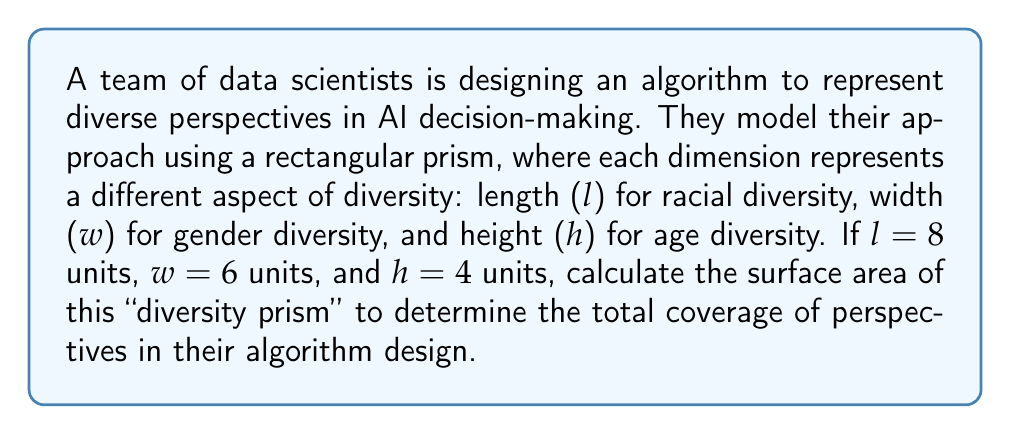Provide a solution to this math problem. To calculate the surface area of a rectangular prism, we need to follow these steps:

1. Recall the formula for the surface area of a rectangular prism:
   $$SA = 2(lw + lh + wh)$$
   where $l$ is length, $w$ is width, and $h$ is height.

2. Substitute the given values:
   $l = 8$, $w = 6$, $h = 4$

3. Calculate each face area:
   - Front/Back face: $lh = 8 \times 4 = 32$
   - Top/Bottom face: $lw = 8 \times 6 = 48$
   - Left/Right face: $wh = 6 \times 4 = 24$

4. Apply the formula:
   $$SA = 2(48 + 32 + 24)$$

5. Simplify:
   $$SA = 2(104) = 208$$

The surface area represents the total coverage of diverse perspectives in the algorithm design, with each square unit symbolizing a unique combination of racial, gender, and age diversity factors.
Answer: 208 square units 